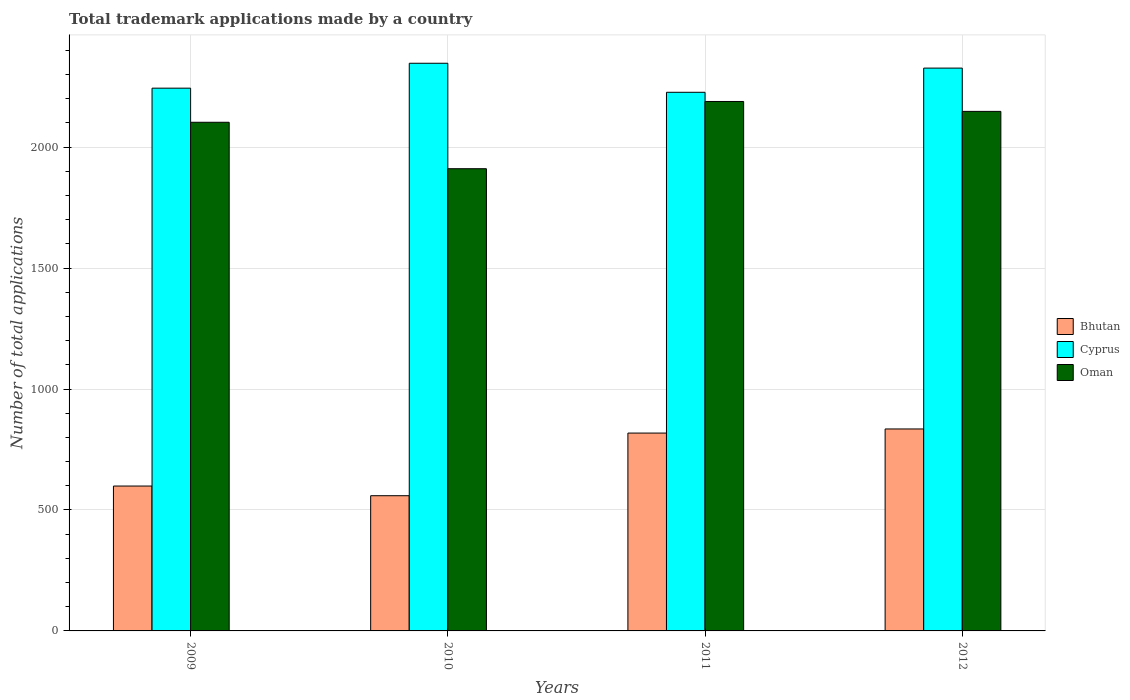How many different coloured bars are there?
Your answer should be very brief. 3. How many groups of bars are there?
Your response must be concise. 4. Are the number of bars per tick equal to the number of legend labels?
Offer a terse response. Yes. Are the number of bars on each tick of the X-axis equal?
Your response must be concise. Yes. How many bars are there on the 1st tick from the left?
Keep it short and to the point. 3. What is the number of applications made by in Cyprus in 2010?
Ensure brevity in your answer.  2347. Across all years, what is the maximum number of applications made by in Bhutan?
Keep it short and to the point. 835. Across all years, what is the minimum number of applications made by in Oman?
Offer a terse response. 1911. In which year was the number of applications made by in Cyprus maximum?
Make the answer very short. 2010. What is the total number of applications made by in Cyprus in the graph?
Your response must be concise. 9145. What is the difference between the number of applications made by in Cyprus in 2009 and that in 2010?
Your response must be concise. -103. What is the difference between the number of applications made by in Bhutan in 2011 and the number of applications made by in Cyprus in 2010?
Give a very brief answer. -1529. What is the average number of applications made by in Bhutan per year?
Offer a very short reply. 702.75. In the year 2010, what is the difference between the number of applications made by in Oman and number of applications made by in Cyprus?
Ensure brevity in your answer.  -436. What is the ratio of the number of applications made by in Cyprus in 2009 to that in 2010?
Provide a succinct answer. 0.96. Is the number of applications made by in Oman in 2011 less than that in 2012?
Your answer should be compact. No. What is the difference between the highest and the second highest number of applications made by in Bhutan?
Your response must be concise. 17. What is the difference between the highest and the lowest number of applications made by in Oman?
Give a very brief answer. 278. Is the sum of the number of applications made by in Bhutan in 2010 and 2011 greater than the maximum number of applications made by in Cyprus across all years?
Offer a terse response. No. What does the 2nd bar from the left in 2011 represents?
Provide a short and direct response. Cyprus. What does the 3rd bar from the right in 2012 represents?
Your answer should be very brief. Bhutan. Is it the case that in every year, the sum of the number of applications made by in Cyprus and number of applications made by in Oman is greater than the number of applications made by in Bhutan?
Offer a terse response. Yes. How many bars are there?
Your response must be concise. 12. How many years are there in the graph?
Your answer should be very brief. 4. How are the legend labels stacked?
Your answer should be very brief. Vertical. What is the title of the graph?
Your answer should be compact. Total trademark applications made by a country. Does "Latin America(developing only)" appear as one of the legend labels in the graph?
Your response must be concise. No. What is the label or title of the Y-axis?
Keep it short and to the point. Number of total applications. What is the Number of total applications in Bhutan in 2009?
Keep it short and to the point. 599. What is the Number of total applications in Cyprus in 2009?
Offer a very short reply. 2244. What is the Number of total applications in Oman in 2009?
Your answer should be very brief. 2103. What is the Number of total applications in Bhutan in 2010?
Ensure brevity in your answer.  559. What is the Number of total applications in Cyprus in 2010?
Provide a short and direct response. 2347. What is the Number of total applications in Oman in 2010?
Give a very brief answer. 1911. What is the Number of total applications in Bhutan in 2011?
Your response must be concise. 818. What is the Number of total applications of Cyprus in 2011?
Ensure brevity in your answer.  2227. What is the Number of total applications in Oman in 2011?
Ensure brevity in your answer.  2189. What is the Number of total applications of Bhutan in 2012?
Give a very brief answer. 835. What is the Number of total applications of Cyprus in 2012?
Keep it short and to the point. 2327. What is the Number of total applications in Oman in 2012?
Your answer should be compact. 2148. Across all years, what is the maximum Number of total applications in Bhutan?
Offer a very short reply. 835. Across all years, what is the maximum Number of total applications in Cyprus?
Provide a succinct answer. 2347. Across all years, what is the maximum Number of total applications in Oman?
Offer a very short reply. 2189. Across all years, what is the minimum Number of total applications in Bhutan?
Your response must be concise. 559. Across all years, what is the minimum Number of total applications in Cyprus?
Ensure brevity in your answer.  2227. Across all years, what is the minimum Number of total applications in Oman?
Your answer should be compact. 1911. What is the total Number of total applications in Bhutan in the graph?
Your answer should be compact. 2811. What is the total Number of total applications of Cyprus in the graph?
Give a very brief answer. 9145. What is the total Number of total applications of Oman in the graph?
Provide a short and direct response. 8351. What is the difference between the Number of total applications in Cyprus in 2009 and that in 2010?
Your response must be concise. -103. What is the difference between the Number of total applications of Oman in 2009 and that in 2010?
Offer a terse response. 192. What is the difference between the Number of total applications in Bhutan in 2009 and that in 2011?
Provide a succinct answer. -219. What is the difference between the Number of total applications of Oman in 2009 and that in 2011?
Your response must be concise. -86. What is the difference between the Number of total applications in Bhutan in 2009 and that in 2012?
Your answer should be compact. -236. What is the difference between the Number of total applications of Cyprus in 2009 and that in 2012?
Make the answer very short. -83. What is the difference between the Number of total applications of Oman in 2009 and that in 2012?
Your answer should be compact. -45. What is the difference between the Number of total applications in Bhutan in 2010 and that in 2011?
Give a very brief answer. -259. What is the difference between the Number of total applications of Cyprus in 2010 and that in 2011?
Offer a terse response. 120. What is the difference between the Number of total applications in Oman in 2010 and that in 2011?
Give a very brief answer. -278. What is the difference between the Number of total applications of Bhutan in 2010 and that in 2012?
Your answer should be very brief. -276. What is the difference between the Number of total applications of Cyprus in 2010 and that in 2012?
Provide a short and direct response. 20. What is the difference between the Number of total applications of Oman in 2010 and that in 2012?
Provide a succinct answer. -237. What is the difference between the Number of total applications in Bhutan in 2011 and that in 2012?
Make the answer very short. -17. What is the difference between the Number of total applications in Cyprus in 2011 and that in 2012?
Your answer should be very brief. -100. What is the difference between the Number of total applications of Bhutan in 2009 and the Number of total applications of Cyprus in 2010?
Provide a succinct answer. -1748. What is the difference between the Number of total applications of Bhutan in 2009 and the Number of total applications of Oman in 2010?
Keep it short and to the point. -1312. What is the difference between the Number of total applications of Cyprus in 2009 and the Number of total applications of Oman in 2010?
Your response must be concise. 333. What is the difference between the Number of total applications in Bhutan in 2009 and the Number of total applications in Cyprus in 2011?
Provide a succinct answer. -1628. What is the difference between the Number of total applications of Bhutan in 2009 and the Number of total applications of Oman in 2011?
Make the answer very short. -1590. What is the difference between the Number of total applications in Bhutan in 2009 and the Number of total applications in Cyprus in 2012?
Ensure brevity in your answer.  -1728. What is the difference between the Number of total applications of Bhutan in 2009 and the Number of total applications of Oman in 2012?
Your response must be concise. -1549. What is the difference between the Number of total applications in Cyprus in 2009 and the Number of total applications in Oman in 2012?
Your response must be concise. 96. What is the difference between the Number of total applications in Bhutan in 2010 and the Number of total applications in Cyprus in 2011?
Provide a short and direct response. -1668. What is the difference between the Number of total applications in Bhutan in 2010 and the Number of total applications in Oman in 2011?
Make the answer very short. -1630. What is the difference between the Number of total applications of Cyprus in 2010 and the Number of total applications of Oman in 2011?
Your response must be concise. 158. What is the difference between the Number of total applications of Bhutan in 2010 and the Number of total applications of Cyprus in 2012?
Give a very brief answer. -1768. What is the difference between the Number of total applications in Bhutan in 2010 and the Number of total applications in Oman in 2012?
Keep it short and to the point. -1589. What is the difference between the Number of total applications in Cyprus in 2010 and the Number of total applications in Oman in 2012?
Keep it short and to the point. 199. What is the difference between the Number of total applications of Bhutan in 2011 and the Number of total applications of Cyprus in 2012?
Provide a succinct answer. -1509. What is the difference between the Number of total applications in Bhutan in 2011 and the Number of total applications in Oman in 2012?
Give a very brief answer. -1330. What is the difference between the Number of total applications in Cyprus in 2011 and the Number of total applications in Oman in 2012?
Keep it short and to the point. 79. What is the average Number of total applications in Bhutan per year?
Keep it short and to the point. 702.75. What is the average Number of total applications of Cyprus per year?
Your answer should be very brief. 2286.25. What is the average Number of total applications of Oman per year?
Keep it short and to the point. 2087.75. In the year 2009, what is the difference between the Number of total applications of Bhutan and Number of total applications of Cyprus?
Offer a terse response. -1645. In the year 2009, what is the difference between the Number of total applications in Bhutan and Number of total applications in Oman?
Give a very brief answer. -1504. In the year 2009, what is the difference between the Number of total applications of Cyprus and Number of total applications of Oman?
Offer a very short reply. 141. In the year 2010, what is the difference between the Number of total applications in Bhutan and Number of total applications in Cyprus?
Give a very brief answer. -1788. In the year 2010, what is the difference between the Number of total applications in Bhutan and Number of total applications in Oman?
Ensure brevity in your answer.  -1352. In the year 2010, what is the difference between the Number of total applications of Cyprus and Number of total applications of Oman?
Make the answer very short. 436. In the year 2011, what is the difference between the Number of total applications in Bhutan and Number of total applications in Cyprus?
Offer a very short reply. -1409. In the year 2011, what is the difference between the Number of total applications in Bhutan and Number of total applications in Oman?
Keep it short and to the point. -1371. In the year 2012, what is the difference between the Number of total applications in Bhutan and Number of total applications in Cyprus?
Offer a very short reply. -1492. In the year 2012, what is the difference between the Number of total applications of Bhutan and Number of total applications of Oman?
Offer a terse response. -1313. In the year 2012, what is the difference between the Number of total applications of Cyprus and Number of total applications of Oman?
Offer a very short reply. 179. What is the ratio of the Number of total applications in Bhutan in 2009 to that in 2010?
Make the answer very short. 1.07. What is the ratio of the Number of total applications in Cyprus in 2009 to that in 2010?
Your answer should be compact. 0.96. What is the ratio of the Number of total applications of Oman in 2009 to that in 2010?
Give a very brief answer. 1.1. What is the ratio of the Number of total applications of Bhutan in 2009 to that in 2011?
Make the answer very short. 0.73. What is the ratio of the Number of total applications in Cyprus in 2009 to that in 2011?
Offer a terse response. 1.01. What is the ratio of the Number of total applications of Oman in 2009 to that in 2011?
Provide a succinct answer. 0.96. What is the ratio of the Number of total applications in Bhutan in 2009 to that in 2012?
Ensure brevity in your answer.  0.72. What is the ratio of the Number of total applications in Cyprus in 2009 to that in 2012?
Keep it short and to the point. 0.96. What is the ratio of the Number of total applications in Oman in 2009 to that in 2012?
Your answer should be very brief. 0.98. What is the ratio of the Number of total applications of Bhutan in 2010 to that in 2011?
Offer a terse response. 0.68. What is the ratio of the Number of total applications in Cyprus in 2010 to that in 2011?
Offer a terse response. 1.05. What is the ratio of the Number of total applications in Oman in 2010 to that in 2011?
Offer a very short reply. 0.87. What is the ratio of the Number of total applications in Bhutan in 2010 to that in 2012?
Your response must be concise. 0.67. What is the ratio of the Number of total applications of Cyprus in 2010 to that in 2012?
Make the answer very short. 1.01. What is the ratio of the Number of total applications in Oman in 2010 to that in 2012?
Give a very brief answer. 0.89. What is the ratio of the Number of total applications in Bhutan in 2011 to that in 2012?
Offer a terse response. 0.98. What is the ratio of the Number of total applications of Oman in 2011 to that in 2012?
Provide a short and direct response. 1.02. What is the difference between the highest and the second highest Number of total applications of Bhutan?
Your response must be concise. 17. What is the difference between the highest and the second highest Number of total applications in Oman?
Your answer should be compact. 41. What is the difference between the highest and the lowest Number of total applications of Bhutan?
Offer a very short reply. 276. What is the difference between the highest and the lowest Number of total applications of Cyprus?
Your answer should be compact. 120. What is the difference between the highest and the lowest Number of total applications of Oman?
Ensure brevity in your answer.  278. 